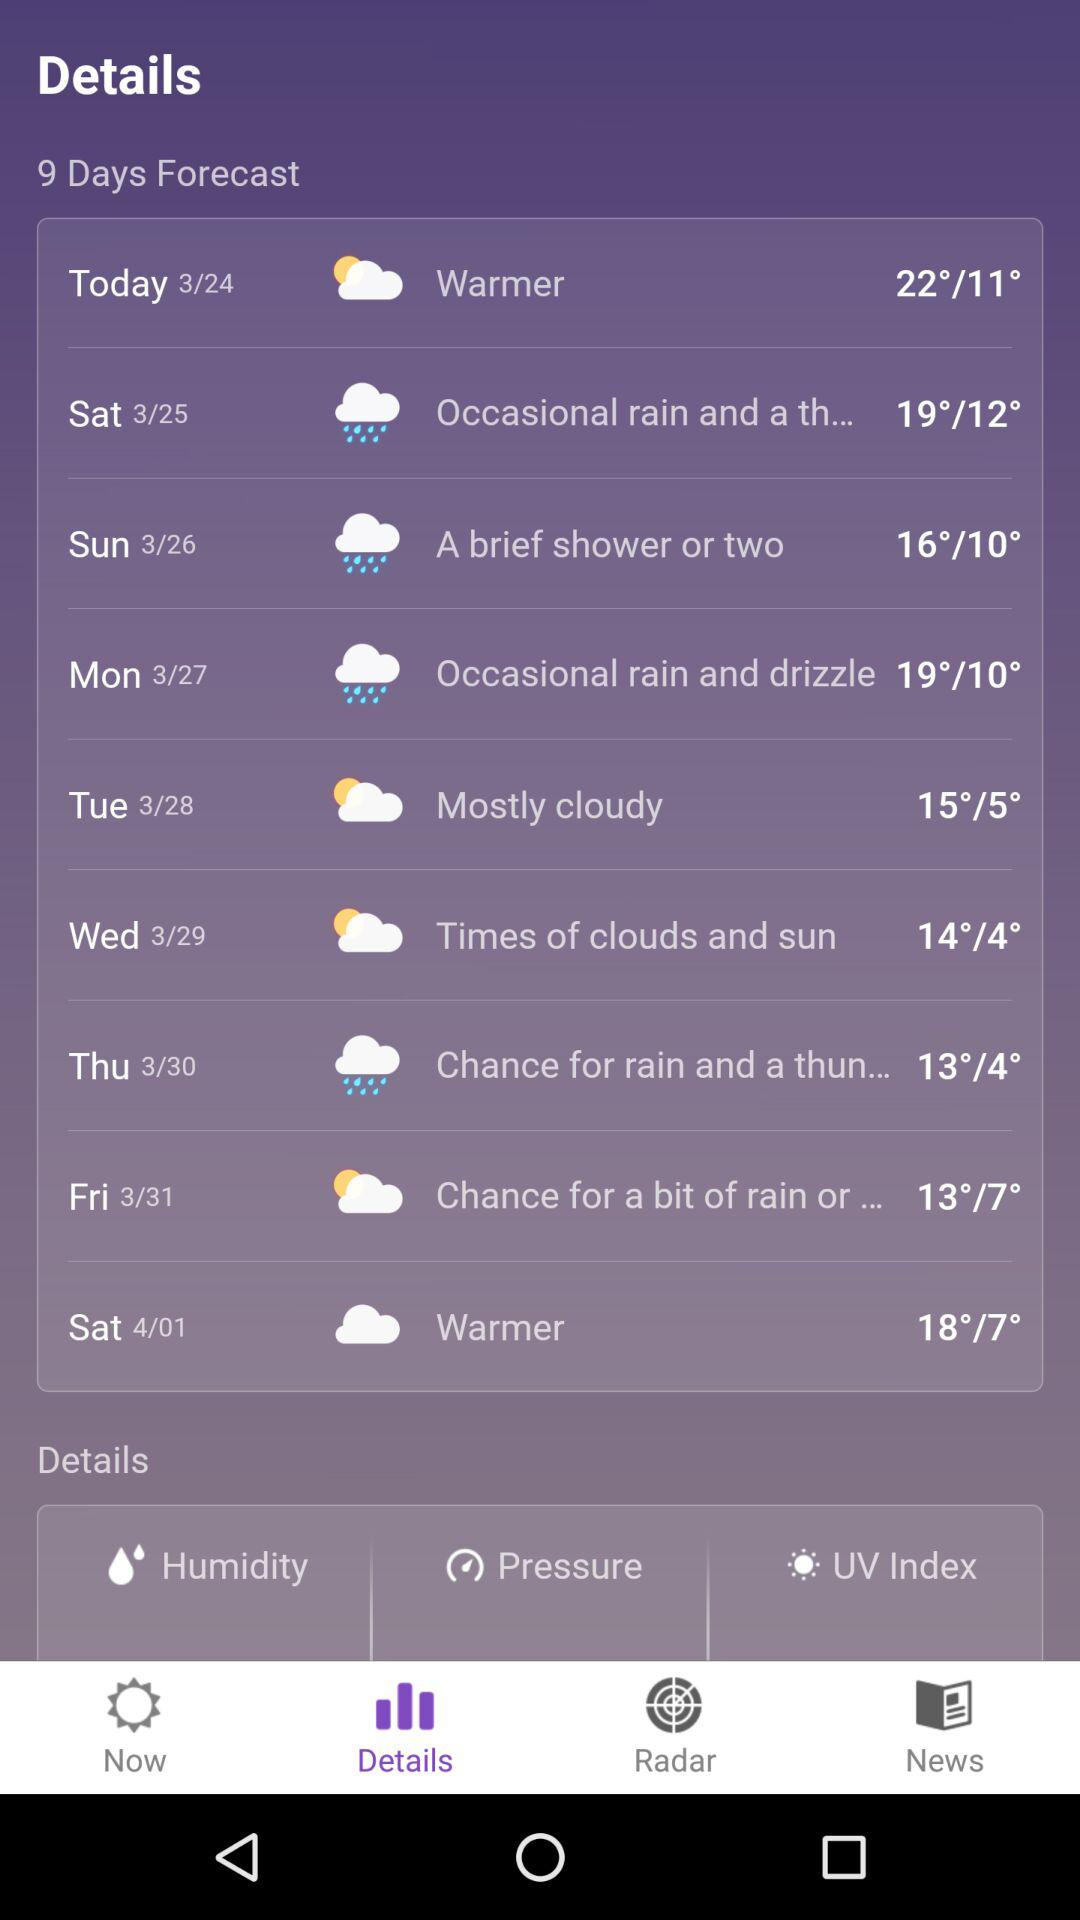What is the temperature for today? The temperature for today is from 22° to 11°. 